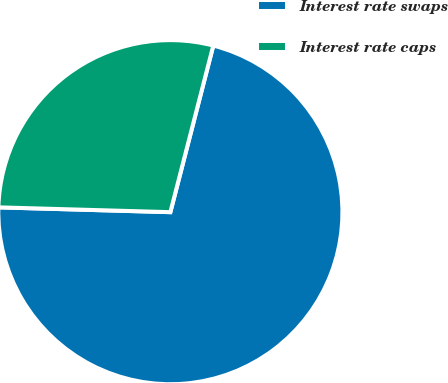Convert chart. <chart><loc_0><loc_0><loc_500><loc_500><pie_chart><fcel>Interest rate swaps<fcel>Interest rate caps<nl><fcel>71.43%<fcel>28.57%<nl></chart> 